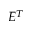<formula> <loc_0><loc_0><loc_500><loc_500>E ^ { T }</formula> 